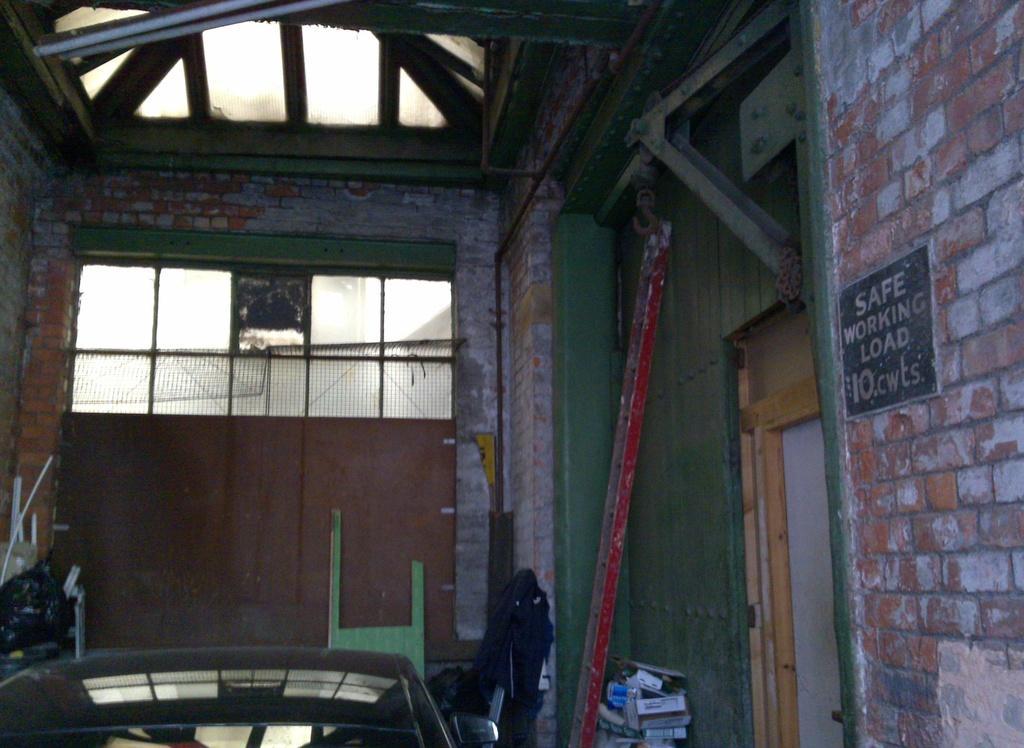In one or two sentences, can you explain what this image depicts? In this picture I can see there is a house and it has a wooden door onto right and there are few objects placed and there is a stone placed on the wall on to right side. 